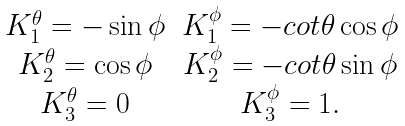Convert formula to latex. <formula><loc_0><loc_0><loc_500><loc_500>\begin{array} { c c } K _ { 1 } ^ { \theta } = - \sin \phi & K _ { 1 } ^ { \phi } = - c o t \theta \cos \phi \\ K _ { 2 } ^ { \theta } = \cos \phi & K _ { 2 } ^ { \phi } = - c o t \theta \sin \phi \\ K _ { 3 } ^ { \theta } = 0 & K _ { 3 } ^ { \phi } = 1 . \end{array}</formula> 